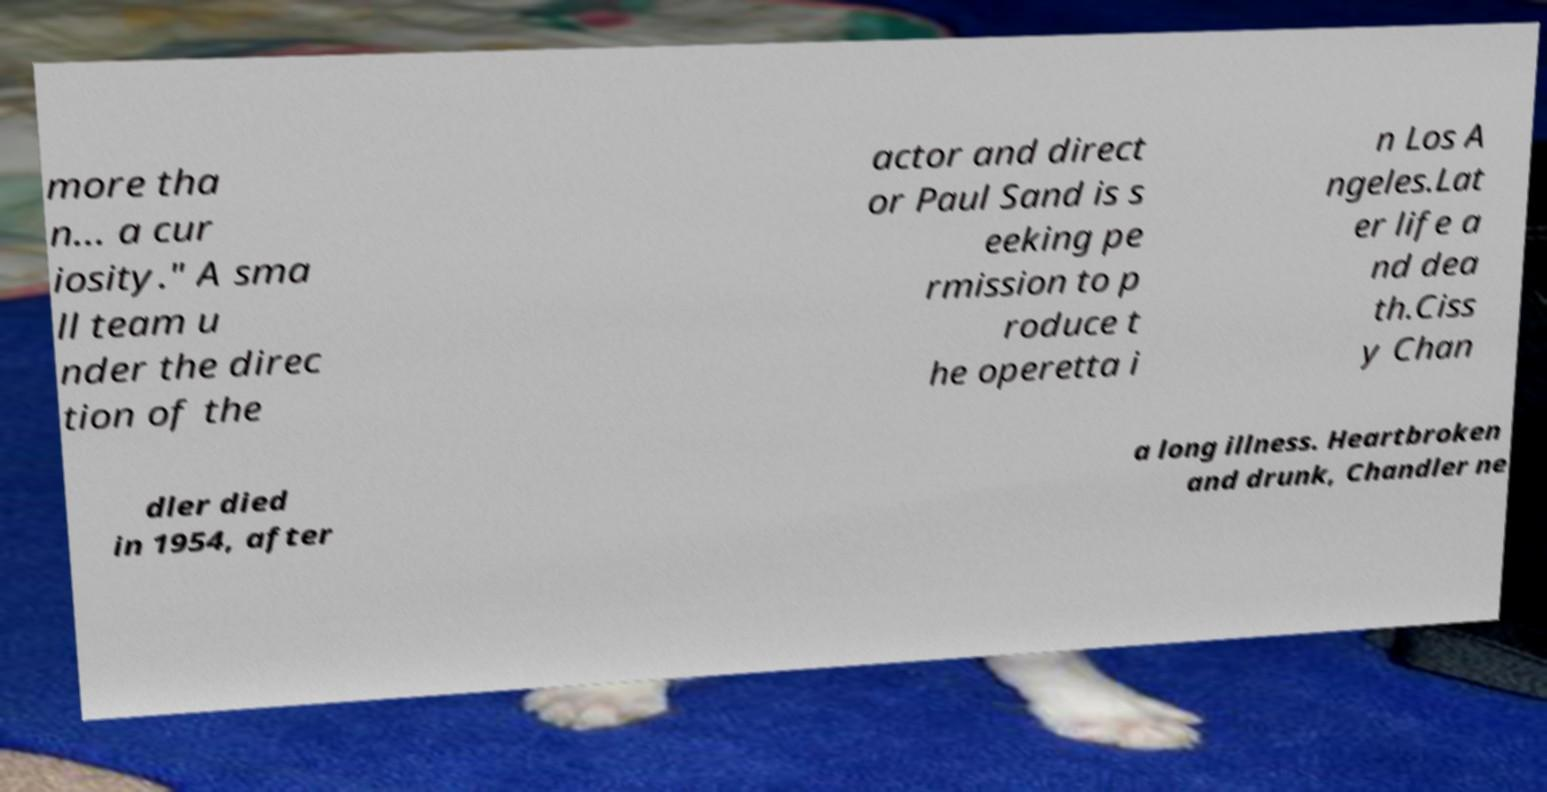Can you read and provide the text displayed in the image?This photo seems to have some interesting text. Can you extract and type it out for me? more tha n… a cur iosity." A sma ll team u nder the direc tion of the actor and direct or Paul Sand is s eeking pe rmission to p roduce t he operetta i n Los A ngeles.Lat er life a nd dea th.Ciss y Chan dler died in 1954, after a long illness. Heartbroken and drunk, Chandler ne 